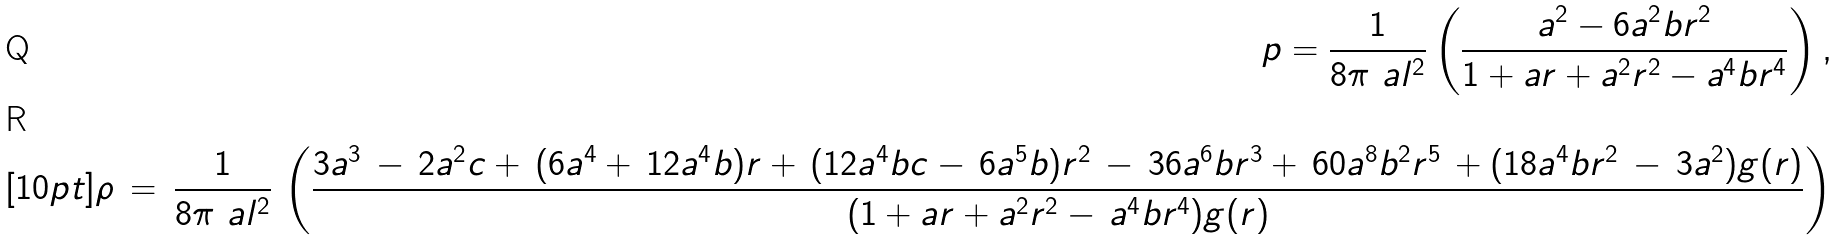Convert formula to latex. <formula><loc_0><loc_0><loc_500><loc_500>p = \frac { 1 } { 8 \pi \ a l ^ { 2 } } \left ( \frac { a ^ { 2 } - 6 a ^ { 2 } b r ^ { 2 } } { 1 + a r + a ^ { 2 } r ^ { 2 } - a ^ { 4 } b r ^ { 4 } } \right ) , \\ [ 1 0 p t ] \rho \, = \, \frac { 1 } { 8 \pi \ a l ^ { 2 } } \, \left ( \frac { 3 a ^ { 3 } \, - \, 2 a ^ { 2 } c + \, ( 6 a ^ { 4 } + \, 1 2 a ^ { 4 } b ) r + \, ( 1 2 a ^ { 4 } b c - \, 6 a ^ { 5 } b ) r ^ { 2 } \, - \, 3 6 a ^ { 6 } b r ^ { 3 } + \, 6 0 a ^ { 8 } b ^ { 2 } r ^ { 5 } \, + ( 1 8 a ^ { 4 } b r ^ { 2 } \, - \, 3 a ^ { 2 } ) g ( r ) } { ( 1 + a r + a ^ { 2 } r ^ { 2 } - \, a ^ { 4 } b r ^ { 4 } ) g ( r ) } \right )</formula> 